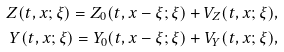Convert formula to latex. <formula><loc_0><loc_0><loc_500><loc_500>Z ( t , x ; \xi ) = Z _ { 0 } ( t , x - \xi ; \xi ) + V _ { Z } ( t , x ; \xi ) , \\ Y ( t , x ; \xi ) = Y _ { 0 } ( t , x - \xi ; \xi ) + V _ { Y } ( t , x ; \xi ) ,</formula> 